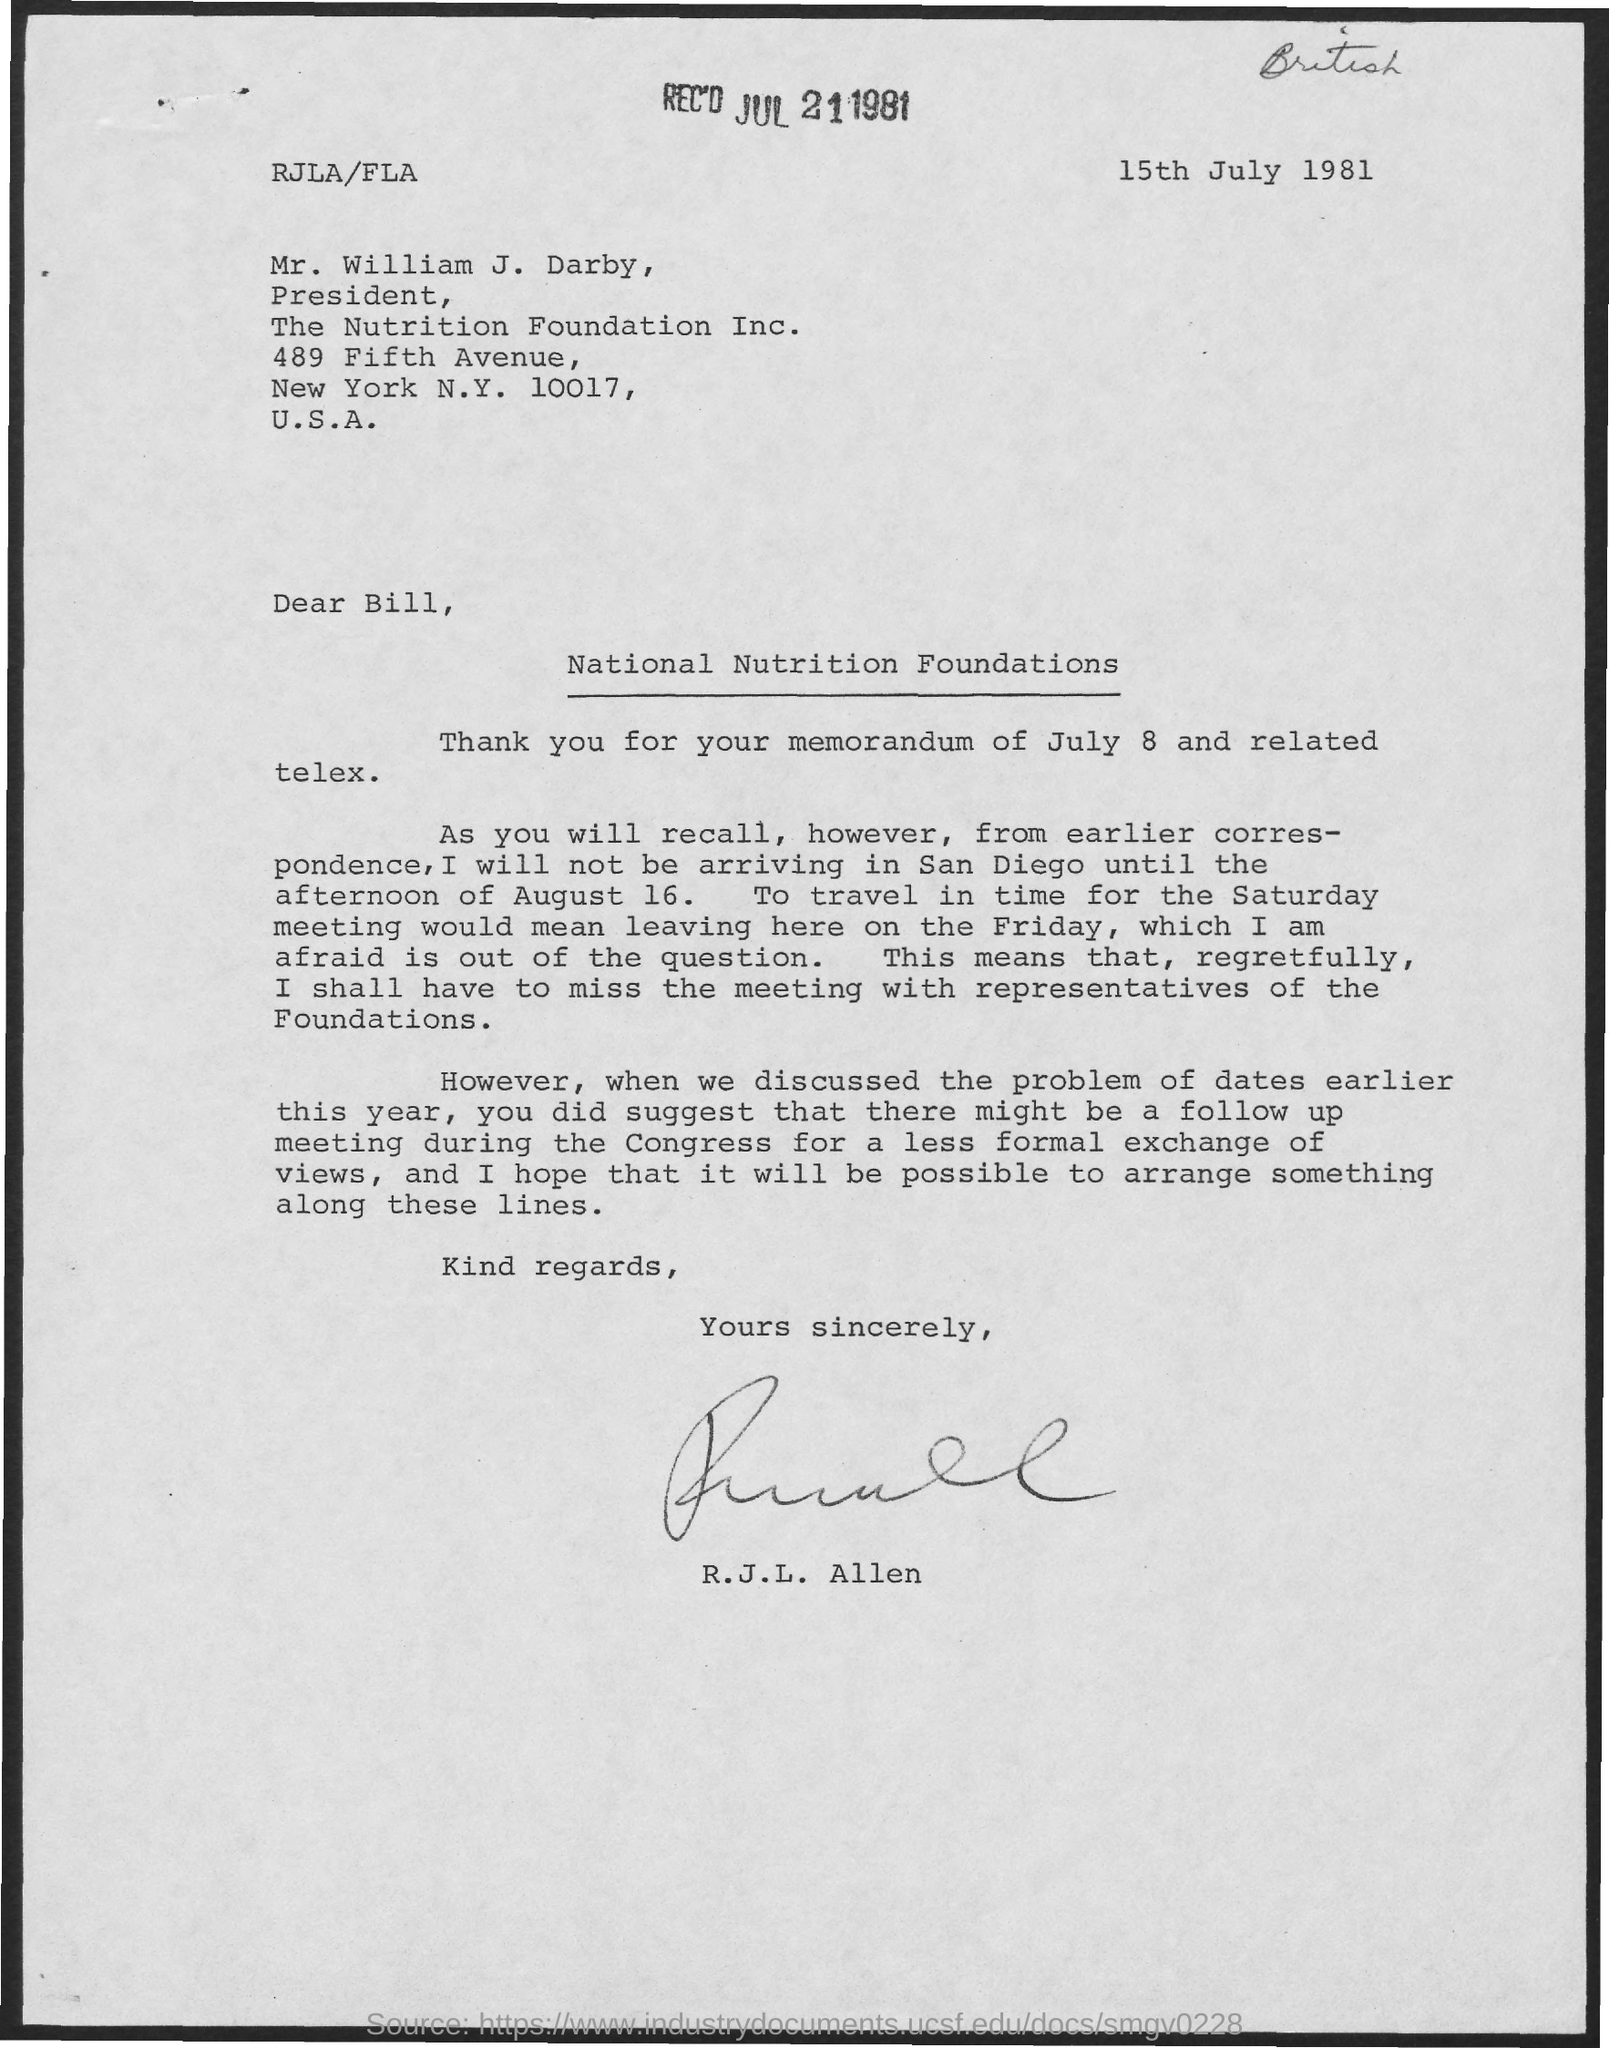Give some essential details in this illustration. The Nutrition Foundation is located in the United States of America. Allen wrote the letter on July 15, 1981. The New York code mentioned in the letter is 10017. 